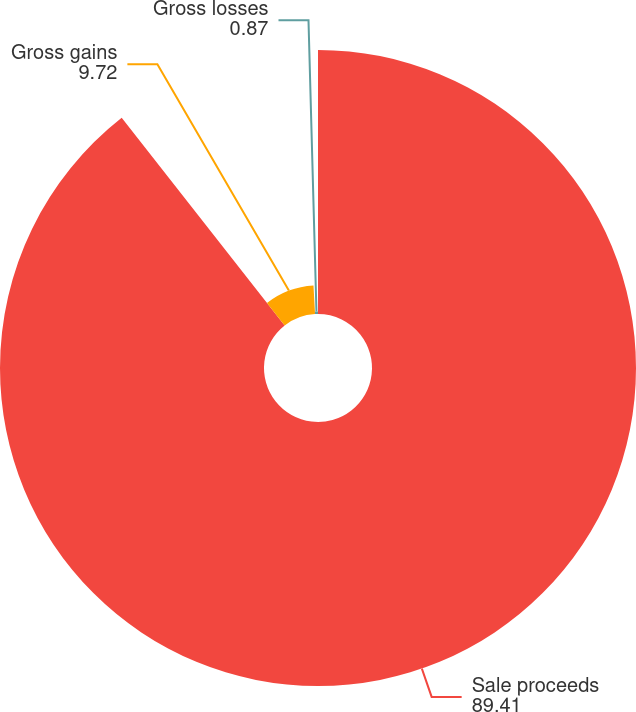<chart> <loc_0><loc_0><loc_500><loc_500><pie_chart><fcel>Sale proceeds<fcel>Gross gains<fcel>Gross losses<nl><fcel>89.41%<fcel>9.72%<fcel>0.87%<nl></chart> 